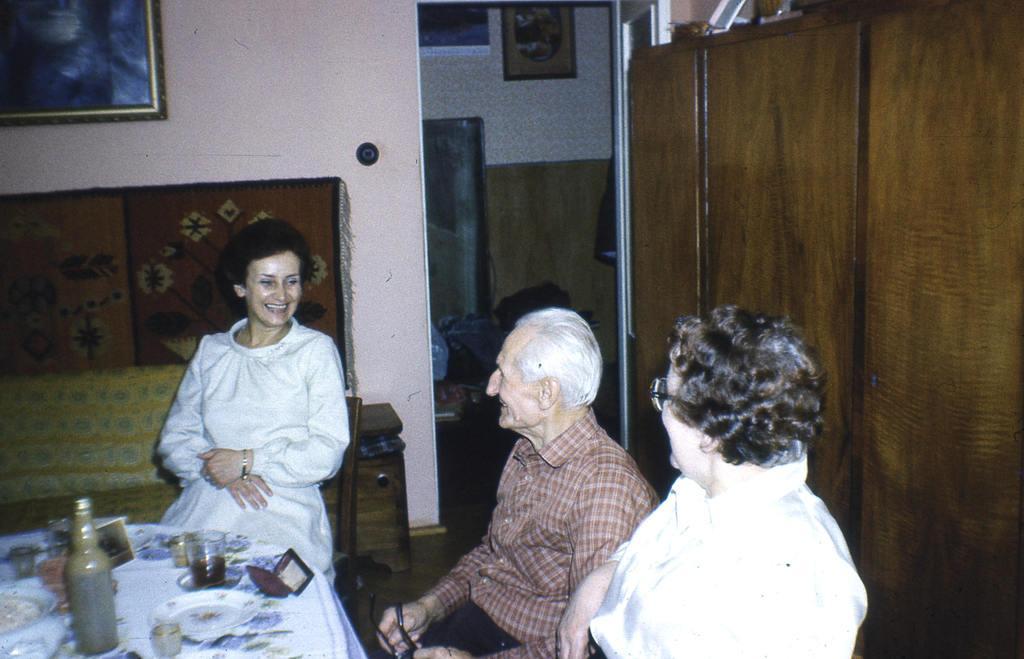Describe this image in one or two sentences. In this image we can see persons sitting on the chairs and a table is placed in front of them. On the table we can see spectacles box, glass tumblers, beverage bottle and crochets. In the background we can see wall hanging attached to the wall, polythene bags and walls. 